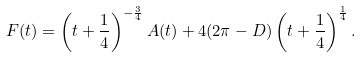Convert formula to latex. <formula><loc_0><loc_0><loc_500><loc_500>F ( t ) = \left ( t + \frac { 1 } { 4 } \right ) ^ { - \frac { 3 } { 4 } } A ( t ) + 4 ( 2 \pi - D ) \left ( t + \frac { 1 } { 4 } \right ) ^ { \frac { 1 } { 4 } } .</formula> 